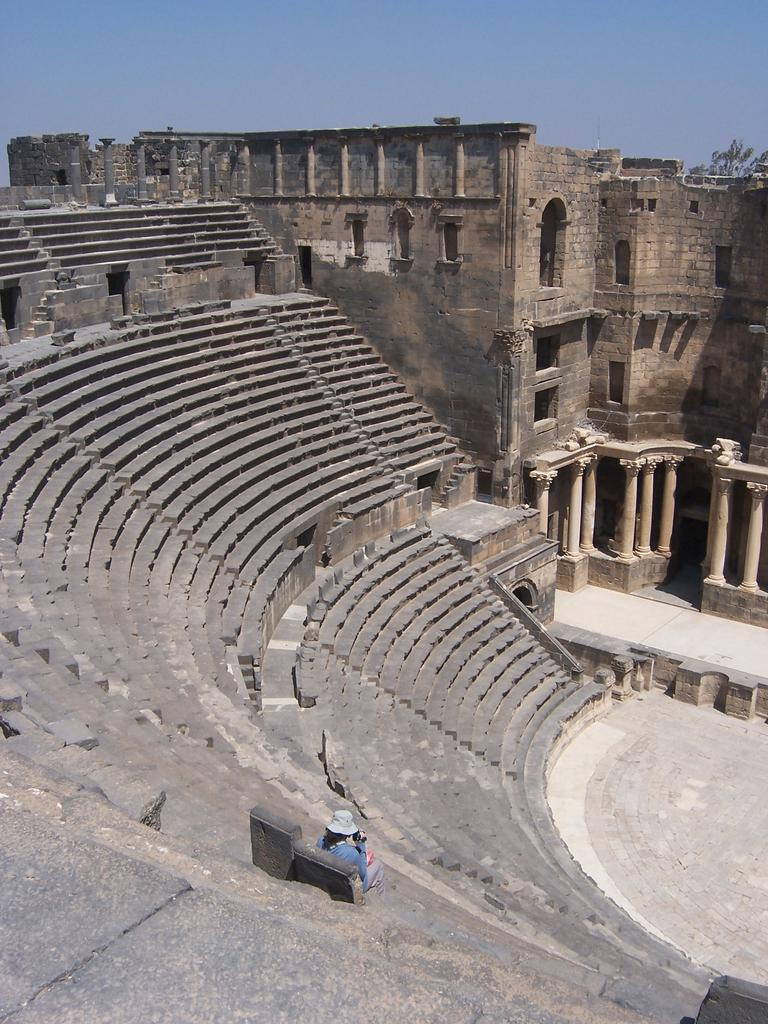What type of structures can be seen in the image? There are buildings in the image. What architectural features are present in the buildings? There are windows and stairs visible in the image. What is the person in the image doing? The person is sitting on a bench in the image. What is visible at the top of the image? The sky is visible at the top of the image. What type of ring can be seen on the person's finger in the image? There is no ring or finger present in the image. Is there any rice visible in the image? There is no rice present in the image. 